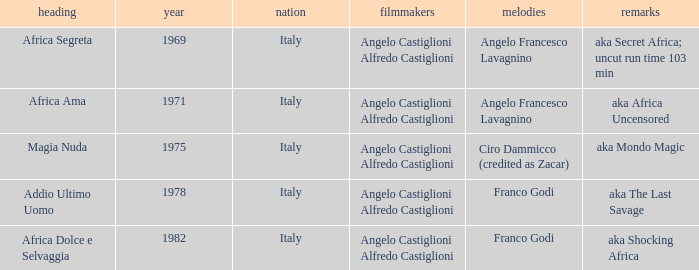How many years have a Title of Magia Nuda? 1.0. 